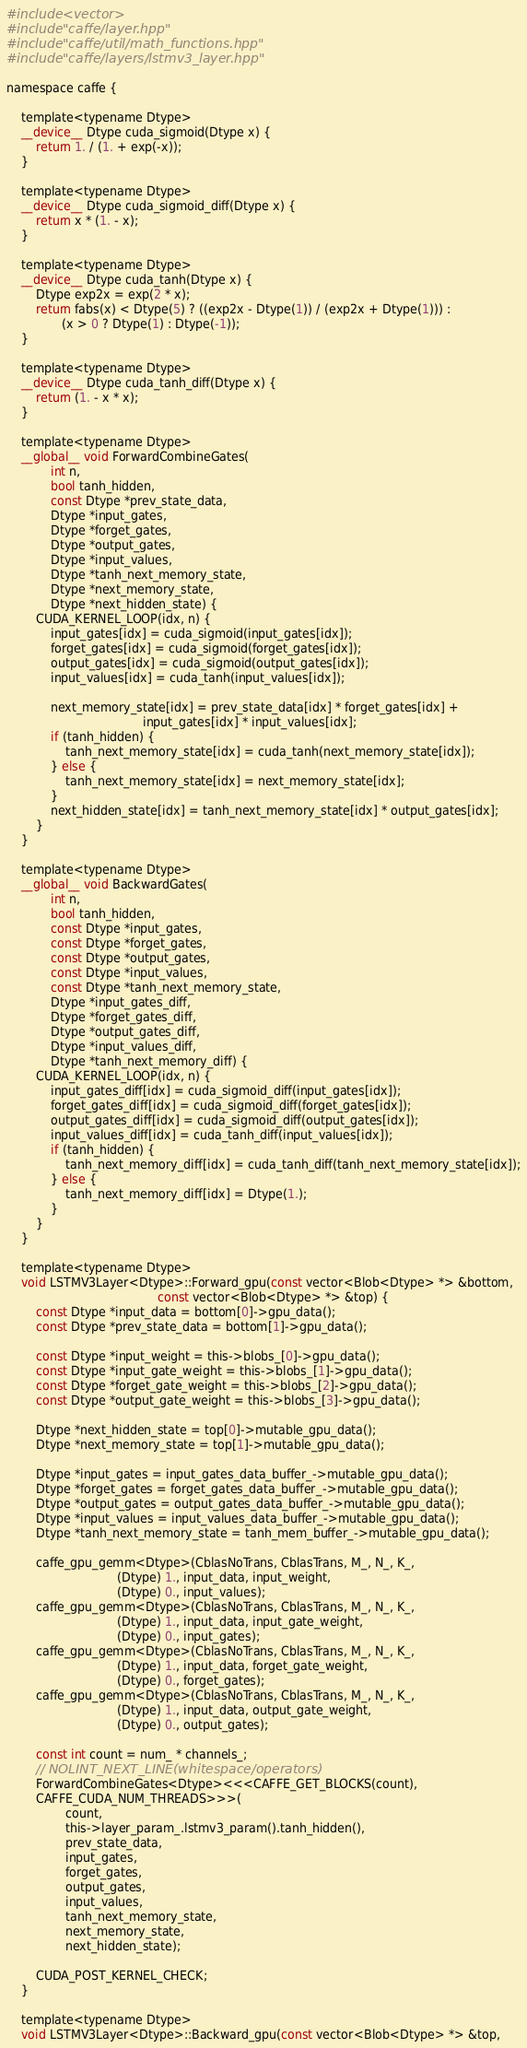<code> <loc_0><loc_0><loc_500><loc_500><_Cuda_>#include <vector>
#include "caffe/layer.hpp"
#include "caffe/util/math_functions.hpp"
#include "caffe/layers/lstmv3_layer.hpp"

namespace caffe {

    template<typename Dtype>
    __device__ Dtype cuda_sigmoid(Dtype x) {
        return 1. / (1. + exp(-x));
    }

    template<typename Dtype>
    __device__ Dtype cuda_sigmoid_diff(Dtype x) {
        return x * (1. - x);
    }

    template<typename Dtype>
    __device__ Dtype cuda_tanh(Dtype x) {
        Dtype exp2x = exp(2 * x);
        return fabs(x) < Dtype(5) ? ((exp2x - Dtype(1)) / (exp2x + Dtype(1))) :
               (x > 0 ? Dtype(1) : Dtype(-1));
    }

    template<typename Dtype>
    __device__ Dtype cuda_tanh_diff(Dtype x) {
        return (1. - x * x);
    }

    template<typename Dtype>
    __global__ void ForwardCombineGates(
            int n,
            bool tanh_hidden,
            const Dtype *prev_state_data,
            Dtype *input_gates,
            Dtype *forget_gates,
            Dtype *output_gates,
            Dtype *input_values,
            Dtype *tanh_next_memory_state,
            Dtype *next_memory_state,
            Dtype *next_hidden_state) {
        CUDA_KERNEL_LOOP(idx, n) {
            input_gates[idx] = cuda_sigmoid(input_gates[idx]);
            forget_gates[idx] = cuda_sigmoid(forget_gates[idx]);
            output_gates[idx] = cuda_sigmoid(output_gates[idx]);
            input_values[idx] = cuda_tanh(input_values[idx]);

            next_memory_state[idx] = prev_state_data[idx] * forget_gates[idx] +
                                     input_gates[idx] * input_values[idx];
            if (tanh_hidden) {
                tanh_next_memory_state[idx] = cuda_tanh(next_memory_state[idx]);
            } else {
                tanh_next_memory_state[idx] = next_memory_state[idx];
            }
            next_hidden_state[idx] = tanh_next_memory_state[idx] * output_gates[idx];
        }
    }

    template<typename Dtype>
    __global__ void BackwardGates(
            int n,
            bool tanh_hidden,
            const Dtype *input_gates,
            const Dtype *forget_gates,
            const Dtype *output_gates,
            const Dtype *input_values,
            const Dtype *tanh_next_memory_state,
            Dtype *input_gates_diff,
            Dtype *forget_gates_diff,
            Dtype *output_gates_diff,
            Dtype *input_values_diff,
            Dtype *tanh_next_memory_diff) {
        CUDA_KERNEL_LOOP(idx, n) {
            input_gates_diff[idx] = cuda_sigmoid_diff(input_gates[idx]);
            forget_gates_diff[idx] = cuda_sigmoid_diff(forget_gates[idx]);
            output_gates_diff[idx] = cuda_sigmoid_diff(output_gates[idx]);
            input_values_diff[idx] = cuda_tanh_diff(input_values[idx]);
            if (tanh_hidden) {
                tanh_next_memory_diff[idx] = cuda_tanh_diff(tanh_next_memory_state[idx]);
            } else {
                tanh_next_memory_diff[idx] = Dtype(1.);
            }
        }
    }

    template<typename Dtype>
    void LSTMV3Layer<Dtype>::Forward_gpu(const vector<Blob<Dtype> *> &bottom,
                                         const vector<Blob<Dtype> *> &top) {
        const Dtype *input_data = bottom[0]->gpu_data();
        const Dtype *prev_state_data = bottom[1]->gpu_data();

        const Dtype *input_weight = this->blobs_[0]->gpu_data();
        const Dtype *input_gate_weight = this->blobs_[1]->gpu_data();
        const Dtype *forget_gate_weight = this->blobs_[2]->gpu_data();
        const Dtype *output_gate_weight = this->blobs_[3]->gpu_data();

        Dtype *next_hidden_state = top[0]->mutable_gpu_data();
        Dtype *next_memory_state = top[1]->mutable_gpu_data();

        Dtype *input_gates = input_gates_data_buffer_->mutable_gpu_data();
        Dtype *forget_gates = forget_gates_data_buffer_->mutable_gpu_data();
        Dtype *output_gates = output_gates_data_buffer_->mutable_gpu_data();
        Dtype *input_values = input_values_data_buffer_->mutable_gpu_data();
        Dtype *tanh_next_memory_state = tanh_mem_buffer_->mutable_gpu_data();

        caffe_gpu_gemm<Dtype>(CblasNoTrans, CblasTrans, M_, N_, K_,
                              (Dtype) 1., input_data, input_weight,
                              (Dtype) 0., input_values);
        caffe_gpu_gemm<Dtype>(CblasNoTrans, CblasTrans, M_, N_, K_,
                              (Dtype) 1., input_data, input_gate_weight,
                              (Dtype) 0., input_gates);
        caffe_gpu_gemm<Dtype>(CblasNoTrans, CblasTrans, M_, N_, K_,
                              (Dtype) 1., input_data, forget_gate_weight,
                              (Dtype) 0., forget_gates);
        caffe_gpu_gemm<Dtype>(CblasNoTrans, CblasTrans, M_, N_, K_,
                              (Dtype) 1., input_data, output_gate_weight,
                              (Dtype) 0., output_gates);

        const int count = num_ * channels_;
        // NOLINT_NEXT_LINE(whitespace/operators)
        ForwardCombineGates<Dtype><<<CAFFE_GET_BLOCKS(count),
        CAFFE_CUDA_NUM_THREADS>>>(
                count,
                this->layer_param_.lstmv3_param().tanh_hidden(),
                prev_state_data,
                input_gates,
                forget_gates,
                output_gates,
                input_values,
                tanh_next_memory_state,
                next_memory_state,
                next_hidden_state);

        CUDA_POST_KERNEL_CHECK;
    }

    template<typename Dtype>
    void LSTMV3Layer<Dtype>::Backward_gpu(const vector<Blob<Dtype> *> &top,</code> 